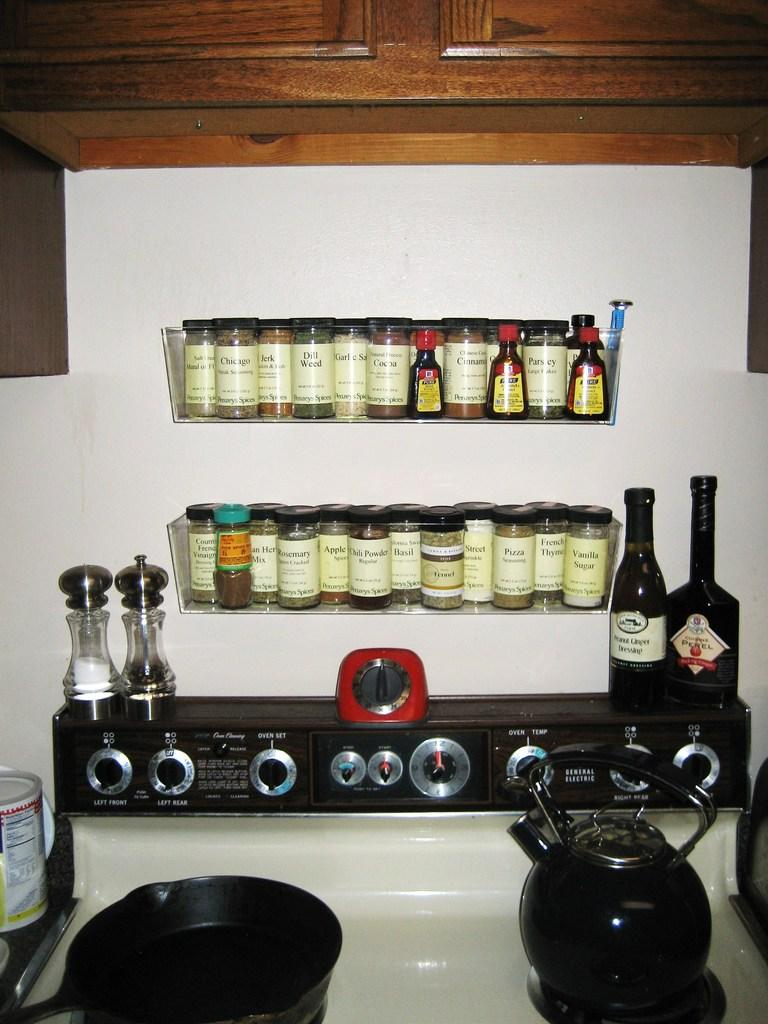Provide a one-sentence caption for the provided image. If you need dill weed, rosemary, or basil, you can find them on this spice rack. 